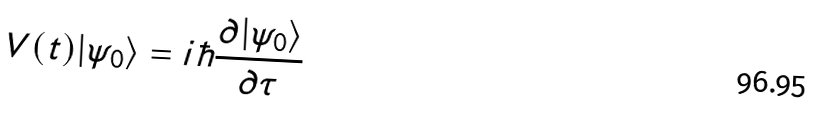Convert formula to latex. <formula><loc_0><loc_0><loc_500><loc_500>V ( t ) | \psi _ { 0 } \rangle = i \hbar { \frac { \partial | \psi _ { 0 } \rangle } { \partial \tau } }</formula> 